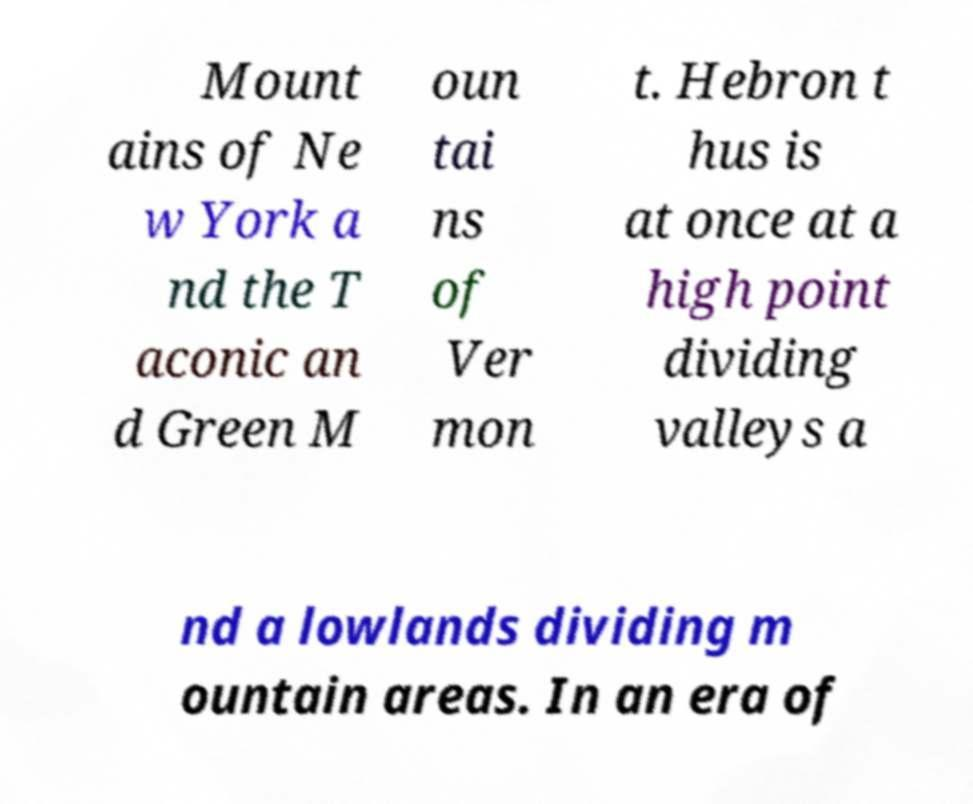What messages or text are displayed in this image? I need them in a readable, typed format. Mount ains of Ne w York a nd the T aconic an d Green M oun tai ns of Ver mon t. Hebron t hus is at once at a high point dividing valleys a nd a lowlands dividing m ountain areas. In an era of 